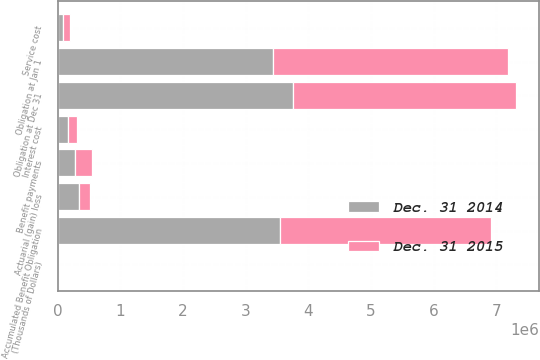Convert chart. <chart><loc_0><loc_0><loc_500><loc_500><stacked_bar_chart><ecel><fcel>(Thousands of Dollars)<fcel>Accumulated Benefit Obligation<fcel>Obligation at Jan 1<fcel>Service cost<fcel>Interest cost<fcel>Actuarial (gain) loss<fcel>Benefit payments<fcel>Obligation at Dec 31<nl><fcel>Dec. 31 2015<fcel>2015<fcel>3.36824e+06<fcel>3.74675e+06<fcel>99311<fcel>148524<fcel>169678<fcel>256982<fcel>3.56793e+06<nl><fcel>Dec. 31 2014<fcel>2014<fcel>3.54593e+06<fcel>3.4407e+06<fcel>88342<fcel>156619<fcel>342826<fcel>281739<fcel>3.74675e+06<nl></chart> 